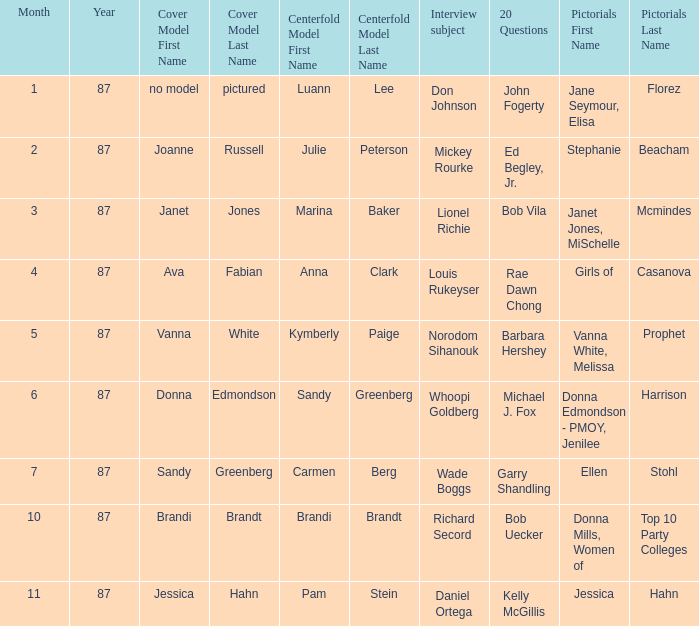When did kymberly paige become the centerfold? 5-87. 